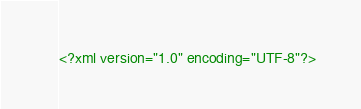Convert code to text. <code><loc_0><loc_0><loc_500><loc_500><_XML_><?xml version="1.0" encoding="UTF-8"?></code> 